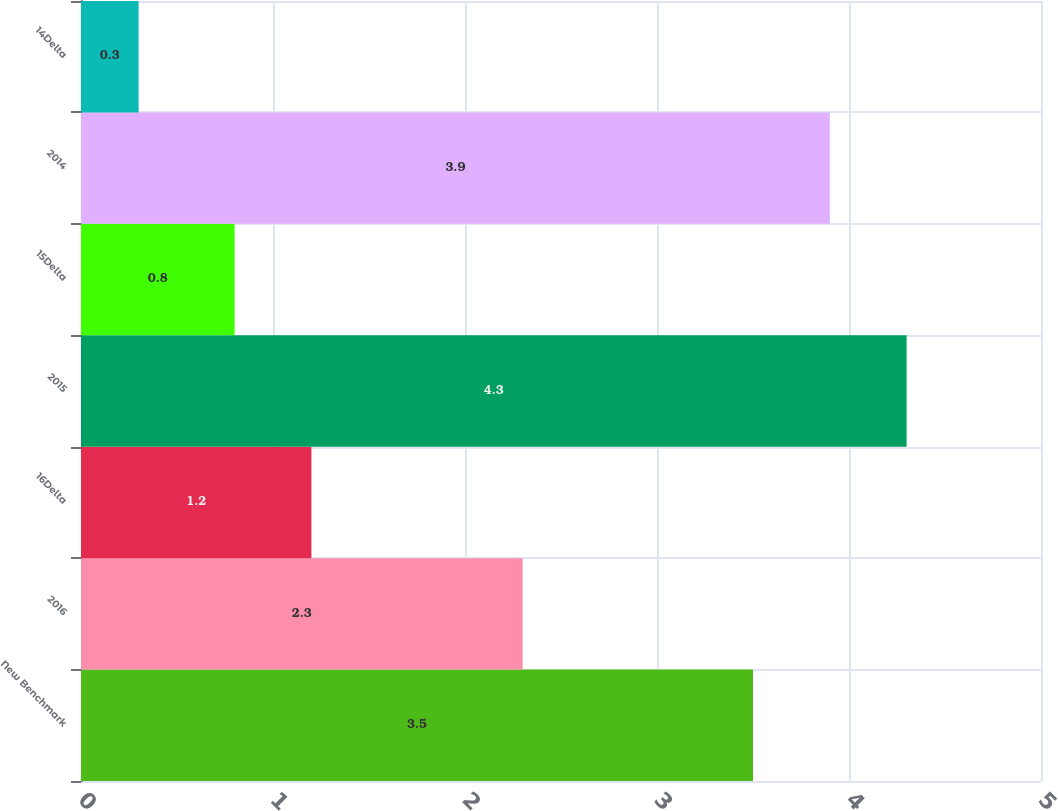Convert chart to OTSL. <chart><loc_0><loc_0><loc_500><loc_500><bar_chart><fcel>New Benchmark<fcel>2016<fcel>16Delta<fcel>2015<fcel>15Delta<fcel>2014<fcel>14Delta<nl><fcel>3.5<fcel>2.3<fcel>1.2<fcel>4.3<fcel>0.8<fcel>3.9<fcel>0.3<nl></chart> 